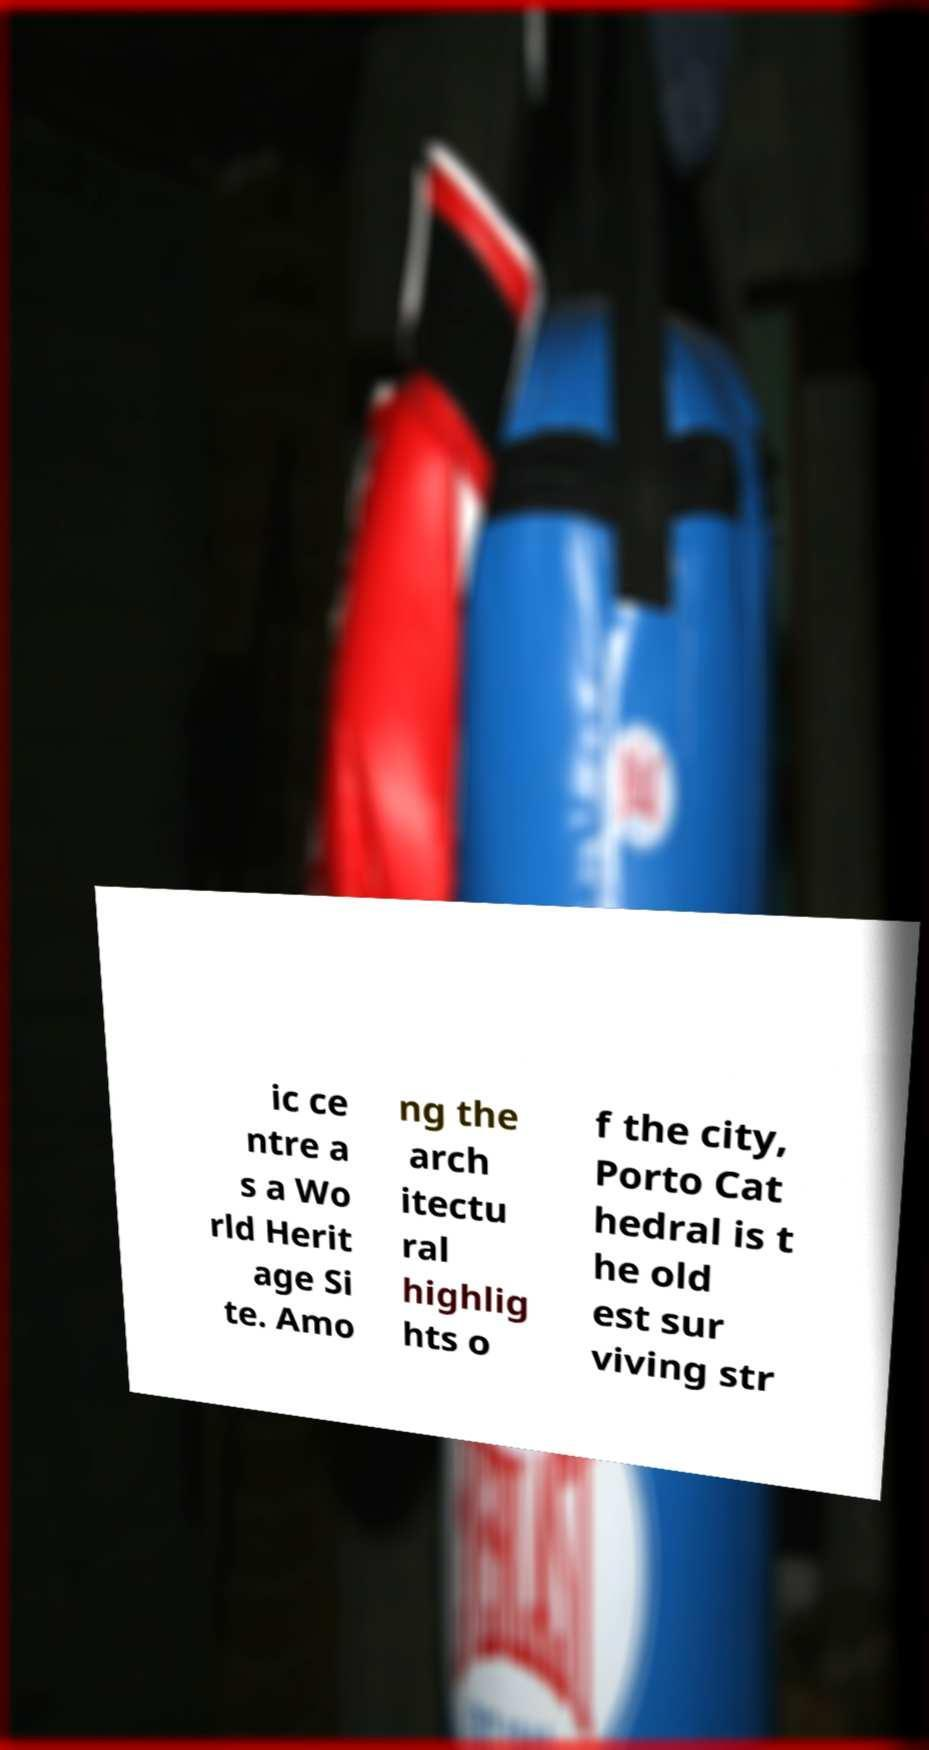There's text embedded in this image that I need extracted. Can you transcribe it verbatim? ic ce ntre a s a Wo rld Herit age Si te. Amo ng the arch itectu ral highlig hts o f the city, Porto Cat hedral is t he old est sur viving str 